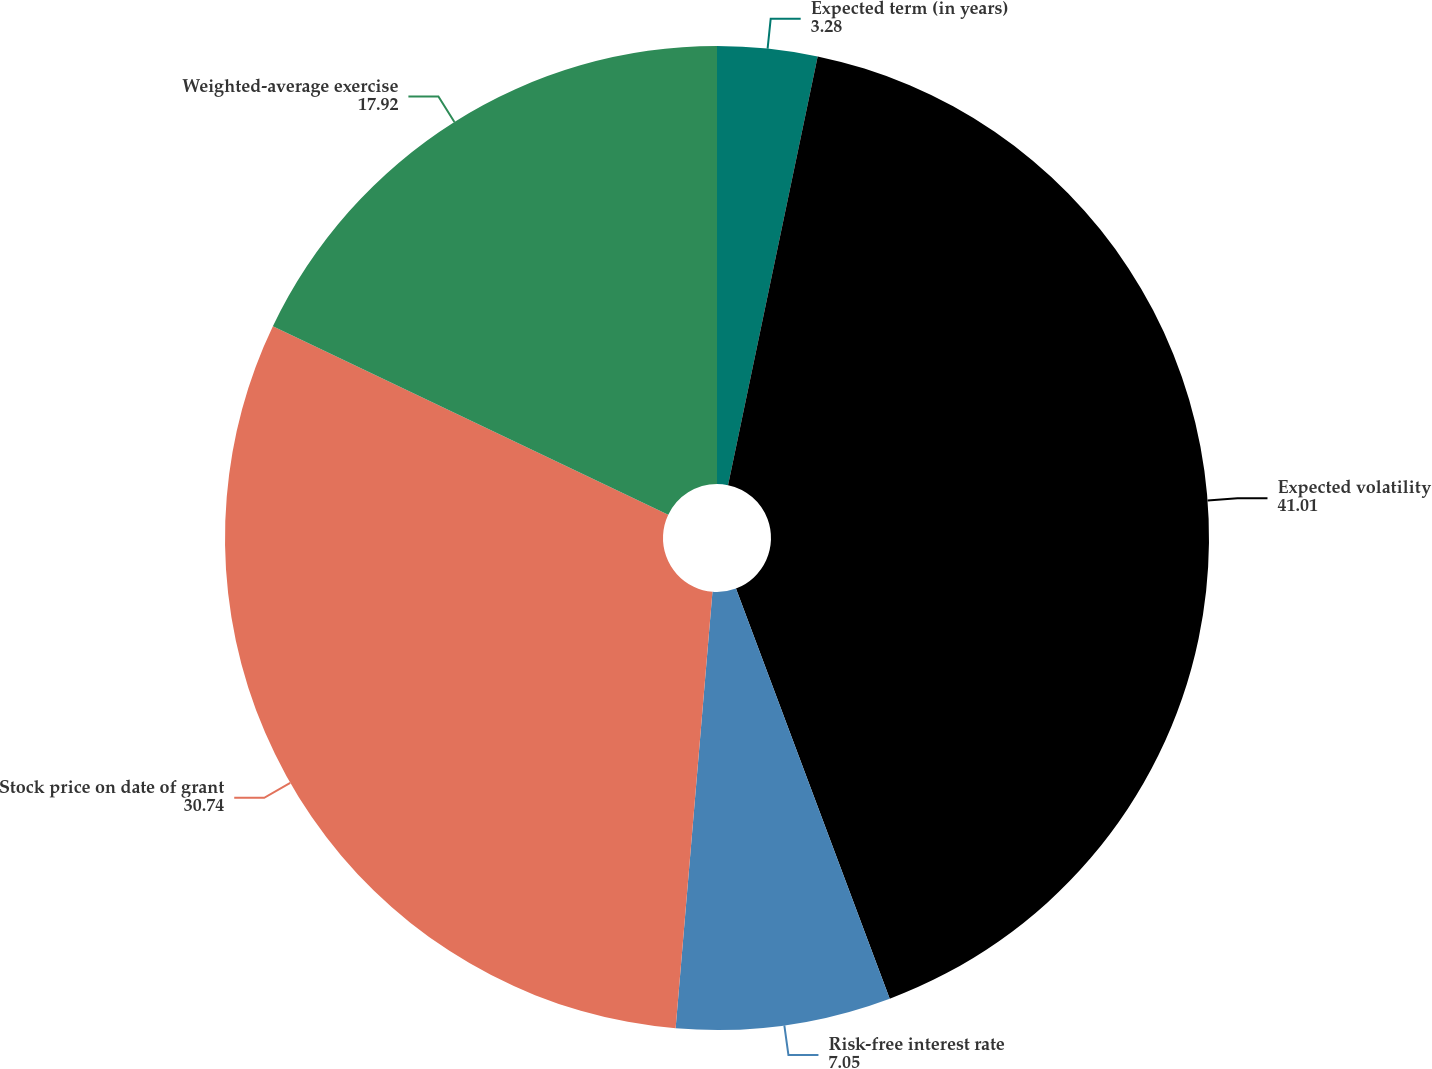<chart> <loc_0><loc_0><loc_500><loc_500><pie_chart><fcel>Expected term (in years)<fcel>Expected volatility<fcel>Risk-free interest rate<fcel>Stock price on date of grant<fcel>Weighted-average exercise<nl><fcel>3.28%<fcel>41.01%<fcel>7.05%<fcel>30.74%<fcel>17.92%<nl></chart> 